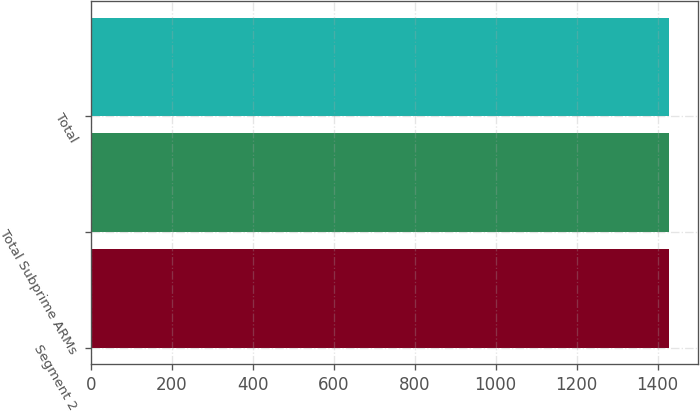<chart> <loc_0><loc_0><loc_500><loc_500><bar_chart><fcel>Segment 2<fcel>Total Subprime ARMs<fcel>Total<nl><fcel>1428<fcel>1428.1<fcel>1428.2<nl></chart> 